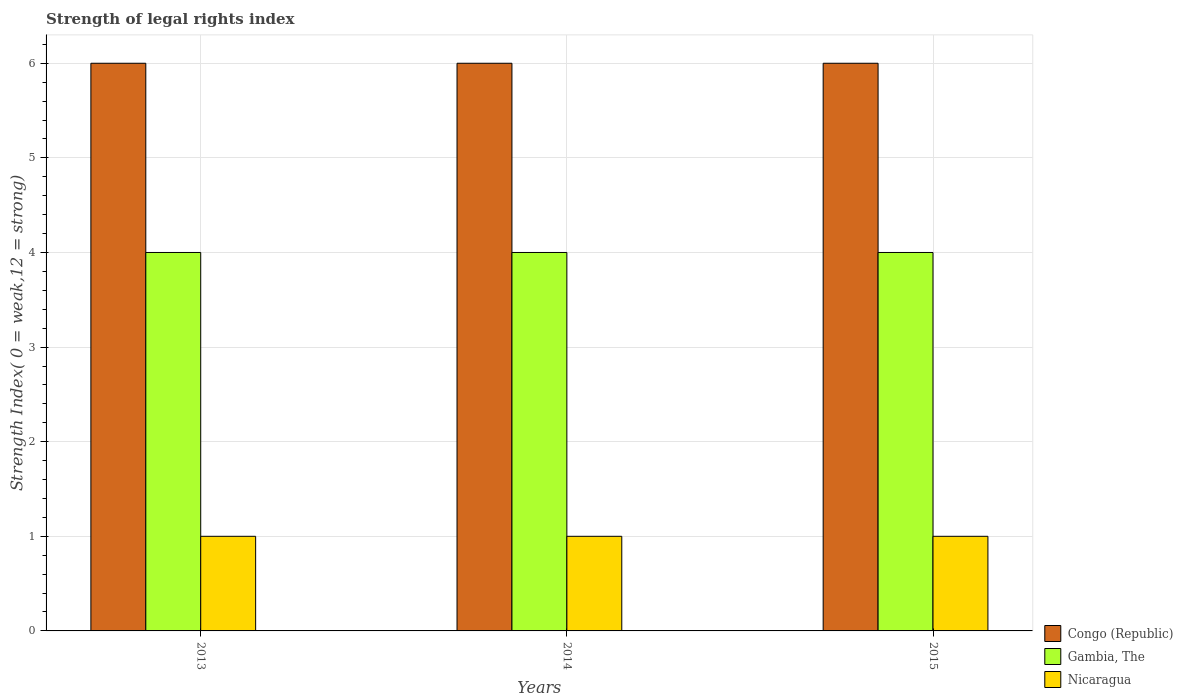How many different coloured bars are there?
Provide a short and direct response. 3. How many bars are there on the 3rd tick from the right?
Make the answer very short. 3. What is the label of the 1st group of bars from the left?
Provide a short and direct response. 2013. Across all years, what is the maximum strength index in Congo (Republic)?
Your answer should be compact. 6. Across all years, what is the minimum strength index in Congo (Republic)?
Your answer should be compact. 6. In which year was the strength index in Congo (Republic) maximum?
Your answer should be compact. 2013. What is the total strength index in Nicaragua in the graph?
Your answer should be very brief. 3. What is the difference between the strength index in Nicaragua in 2014 and the strength index in Congo (Republic) in 2013?
Provide a succinct answer. -5. What is the average strength index in Congo (Republic) per year?
Your answer should be very brief. 6. In the year 2013, what is the difference between the strength index in Congo (Republic) and strength index in Nicaragua?
Offer a terse response. 5. Is the difference between the strength index in Congo (Republic) in 2014 and 2015 greater than the difference between the strength index in Nicaragua in 2014 and 2015?
Your response must be concise. No. What is the difference between the highest and the lowest strength index in Congo (Republic)?
Give a very brief answer. 0. What does the 2nd bar from the left in 2014 represents?
Your response must be concise. Gambia, The. What does the 1st bar from the right in 2013 represents?
Keep it short and to the point. Nicaragua. How many bars are there?
Ensure brevity in your answer.  9. How many years are there in the graph?
Your answer should be very brief. 3. What is the difference between two consecutive major ticks on the Y-axis?
Your answer should be very brief. 1. Are the values on the major ticks of Y-axis written in scientific E-notation?
Make the answer very short. No. Does the graph contain any zero values?
Ensure brevity in your answer.  No. Does the graph contain grids?
Ensure brevity in your answer.  Yes. Where does the legend appear in the graph?
Your answer should be compact. Bottom right. How many legend labels are there?
Your answer should be compact. 3. How are the legend labels stacked?
Ensure brevity in your answer.  Vertical. What is the title of the graph?
Offer a very short reply. Strength of legal rights index. What is the label or title of the Y-axis?
Offer a very short reply. Strength Index( 0 = weak,12 = strong). What is the Strength Index( 0 = weak,12 = strong) in Gambia, The in 2013?
Keep it short and to the point. 4. What is the Strength Index( 0 = weak,12 = strong) of Congo (Republic) in 2014?
Provide a succinct answer. 6. What is the Strength Index( 0 = weak,12 = strong) of Nicaragua in 2014?
Your response must be concise. 1. Across all years, what is the minimum Strength Index( 0 = weak,12 = strong) in Nicaragua?
Provide a succinct answer. 1. What is the total Strength Index( 0 = weak,12 = strong) in Gambia, The in the graph?
Provide a short and direct response. 12. What is the total Strength Index( 0 = weak,12 = strong) of Nicaragua in the graph?
Offer a very short reply. 3. What is the difference between the Strength Index( 0 = weak,12 = strong) in Gambia, The in 2013 and that in 2014?
Offer a very short reply. 0. What is the difference between the Strength Index( 0 = weak,12 = strong) in Nicaragua in 2013 and that in 2014?
Your response must be concise. 0. What is the difference between the Strength Index( 0 = weak,12 = strong) of Gambia, The in 2013 and that in 2015?
Provide a succinct answer. 0. What is the difference between the Strength Index( 0 = weak,12 = strong) in Nicaragua in 2013 and that in 2015?
Offer a very short reply. 0. What is the difference between the Strength Index( 0 = weak,12 = strong) in Congo (Republic) in 2014 and that in 2015?
Make the answer very short. 0. What is the difference between the Strength Index( 0 = weak,12 = strong) in Gambia, The in 2013 and the Strength Index( 0 = weak,12 = strong) in Nicaragua in 2014?
Your answer should be very brief. 3. What is the difference between the Strength Index( 0 = weak,12 = strong) in Congo (Republic) in 2013 and the Strength Index( 0 = weak,12 = strong) in Nicaragua in 2015?
Provide a succinct answer. 5. What is the difference between the Strength Index( 0 = weak,12 = strong) of Congo (Republic) in 2014 and the Strength Index( 0 = weak,12 = strong) of Gambia, The in 2015?
Your answer should be compact. 2. What is the average Strength Index( 0 = weak,12 = strong) of Gambia, The per year?
Keep it short and to the point. 4. What is the average Strength Index( 0 = weak,12 = strong) in Nicaragua per year?
Keep it short and to the point. 1. In the year 2013, what is the difference between the Strength Index( 0 = weak,12 = strong) in Congo (Republic) and Strength Index( 0 = weak,12 = strong) in Nicaragua?
Provide a short and direct response. 5. In the year 2014, what is the difference between the Strength Index( 0 = weak,12 = strong) in Congo (Republic) and Strength Index( 0 = weak,12 = strong) in Nicaragua?
Make the answer very short. 5. In the year 2014, what is the difference between the Strength Index( 0 = weak,12 = strong) of Gambia, The and Strength Index( 0 = weak,12 = strong) of Nicaragua?
Offer a very short reply. 3. In the year 2015, what is the difference between the Strength Index( 0 = weak,12 = strong) of Congo (Republic) and Strength Index( 0 = weak,12 = strong) of Gambia, The?
Your response must be concise. 2. In the year 2015, what is the difference between the Strength Index( 0 = weak,12 = strong) of Gambia, The and Strength Index( 0 = weak,12 = strong) of Nicaragua?
Give a very brief answer. 3. What is the ratio of the Strength Index( 0 = weak,12 = strong) of Congo (Republic) in 2013 to that in 2014?
Keep it short and to the point. 1. What is the ratio of the Strength Index( 0 = weak,12 = strong) in Congo (Republic) in 2013 to that in 2015?
Your answer should be very brief. 1. What is the ratio of the Strength Index( 0 = weak,12 = strong) of Congo (Republic) in 2014 to that in 2015?
Ensure brevity in your answer.  1. What is the ratio of the Strength Index( 0 = weak,12 = strong) in Nicaragua in 2014 to that in 2015?
Your answer should be compact. 1. What is the difference between the highest and the second highest Strength Index( 0 = weak,12 = strong) of Congo (Republic)?
Give a very brief answer. 0. What is the difference between the highest and the second highest Strength Index( 0 = weak,12 = strong) in Gambia, The?
Keep it short and to the point. 0. What is the difference between the highest and the lowest Strength Index( 0 = weak,12 = strong) of Congo (Republic)?
Your answer should be compact. 0. What is the difference between the highest and the lowest Strength Index( 0 = weak,12 = strong) in Gambia, The?
Your answer should be very brief. 0. What is the difference between the highest and the lowest Strength Index( 0 = weak,12 = strong) of Nicaragua?
Ensure brevity in your answer.  0. 